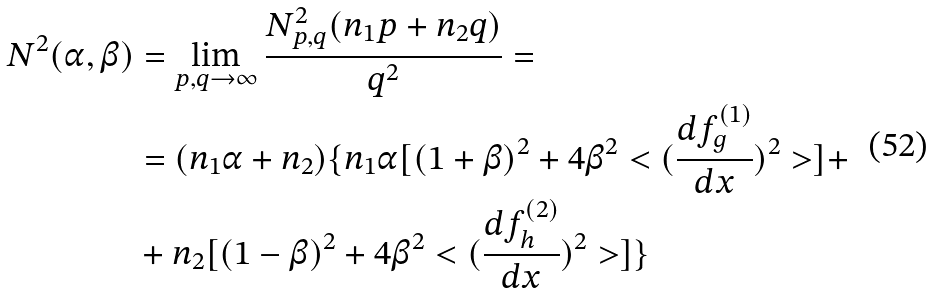<formula> <loc_0><loc_0><loc_500><loc_500>N ^ { 2 } ( \alpha , \beta ) & = \lim _ { p , q \rightarrow \infty } \frac { N ^ { 2 } _ { p , q } ( n _ { 1 } p + n _ { 2 } q ) } { q ^ { 2 } } = \\ & = ( n _ { 1 } \alpha + n _ { 2 } ) \{ n _ { 1 } \alpha [ ( 1 + \beta ) ^ { 2 } + 4 \beta ^ { 2 } < ( \frac { d f ^ { ( 1 ) } _ { g } } { d x } ) ^ { 2 } > ] + \\ & + n _ { 2 } [ ( 1 - \beta ) ^ { 2 } + 4 \beta ^ { 2 } < ( \frac { d f ^ { ( 2 ) } _ { h } } { d x } ) ^ { 2 } > ] \}</formula> 